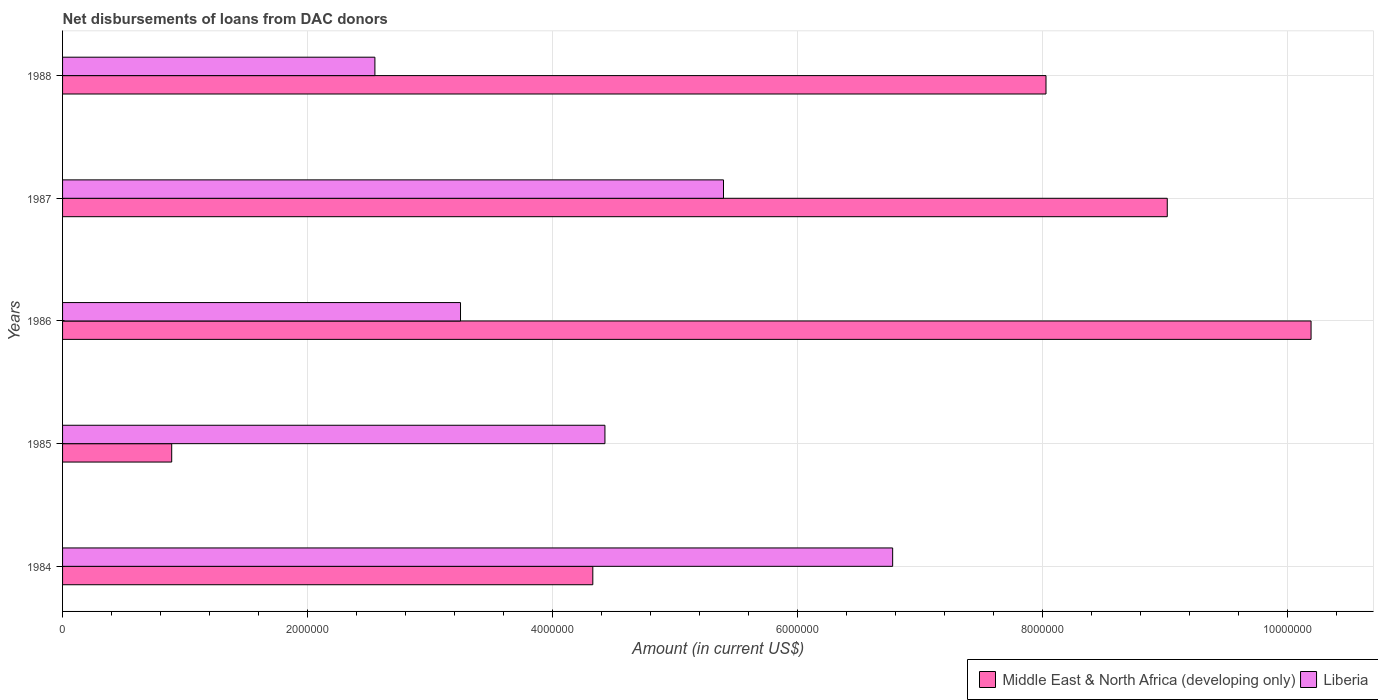Are the number of bars per tick equal to the number of legend labels?
Your response must be concise. Yes. Are the number of bars on each tick of the Y-axis equal?
Your answer should be very brief. Yes. In how many cases, is the number of bars for a given year not equal to the number of legend labels?
Provide a succinct answer. 0. What is the amount of loans disbursed in Liberia in 1988?
Your response must be concise. 2.55e+06. Across all years, what is the maximum amount of loans disbursed in Liberia?
Make the answer very short. 6.78e+06. Across all years, what is the minimum amount of loans disbursed in Liberia?
Provide a short and direct response. 2.55e+06. In which year was the amount of loans disbursed in Liberia maximum?
Your answer should be very brief. 1984. What is the total amount of loans disbursed in Middle East & North Africa (developing only) in the graph?
Provide a short and direct response. 3.25e+07. What is the difference between the amount of loans disbursed in Liberia in 1986 and that in 1987?
Offer a terse response. -2.15e+06. What is the difference between the amount of loans disbursed in Middle East & North Africa (developing only) in 1984 and the amount of loans disbursed in Liberia in 1986?
Offer a very short reply. 1.08e+06. What is the average amount of loans disbursed in Middle East & North Africa (developing only) per year?
Ensure brevity in your answer.  6.49e+06. In the year 1987, what is the difference between the amount of loans disbursed in Liberia and amount of loans disbursed in Middle East & North Africa (developing only)?
Provide a succinct answer. -3.62e+06. In how many years, is the amount of loans disbursed in Liberia greater than 2000000 US$?
Keep it short and to the point. 5. What is the ratio of the amount of loans disbursed in Middle East & North Africa (developing only) in 1984 to that in 1987?
Provide a short and direct response. 0.48. What is the difference between the highest and the second highest amount of loans disbursed in Middle East & North Africa (developing only)?
Your answer should be very brief. 1.17e+06. What is the difference between the highest and the lowest amount of loans disbursed in Liberia?
Make the answer very short. 4.23e+06. In how many years, is the amount of loans disbursed in Middle East & North Africa (developing only) greater than the average amount of loans disbursed in Middle East & North Africa (developing only) taken over all years?
Your response must be concise. 3. Is the sum of the amount of loans disbursed in Liberia in 1985 and 1988 greater than the maximum amount of loans disbursed in Middle East & North Africa (developing only) across all years?
Ensure brevity in your answer.  No. What does the 2nd bar from the top in 1984 represents?
Provide a succinct answer. Middle East & North Africa (developing only). What does the 2nd bar from the bottom in 1987 represents?
Your response must be concise. Liberia. Are all the bars in the graph horizontal?
Make the answer very short. Yes. Where does the legend appear in the graph?
Offer a very short reply. Bottom right. What is the title of the graph?
Your answer should be compact. Net disbursements of loans from DAC donors. Does "Zambia" appear as one of the legend labels in the graph?
Ensure brevity in your answer.  No. What is the label or title of the X-axis?
Provide a succinct answer. Amount (in current US$). What is the Amount (in current US$) in Middle East & North Africa (developing only) in 1984?
Your response must be concise. 4.33e+06. What is the Amount (in current US$) in Liberia in 1984?
Offer a very short reply. 6.78e+06. What is the Amount (in current US$) of Middle East & North Africa (developing only) in 1985?
Provide a succinct answer. 8.91e+05. What is the Amount (in current US$) of Liberia in 1985?
Keep it short and to the point. 4.43e+06. What is the Amount (in current US$) of Middle East & North Africa (developing only) in 1986?
Offer a very short reply. 1.02e+07. What is the Amount (in current US$) in Liberia in 1986?
Provide a succinct answer. 3.25e+06. What is the Amount (in current US$) of Middle East & North Africa (developing only) in 1987?
Provide a short and direct response. 9.02e+06. What is the Amount (in current US$) in Liberia in 1987?
Offer a very short reply. 5.40e+06. What is the Amount (in current US$) of Middle East & North Africa (developing only) in 1988?
Give a very brief answer. 8.03e+06. What is the Amount (in current US$) of Liberia in 1988?
Make the answer very short. 2.55e+06. Across all years, what is the maximum Amount (in current US$) of Middle East & North Africa (developing only)?
Your answer should be very brief. 1.02e+07. Across all years, what is the maximum Amount (in current US$) in Liberia?
Your answer should be very brief. 6.78e+06. Across all years, what is the minimum Amount (in current US$) of Middle East & North Africa (developing only)?
Ensure brevity in your answer.  8.91e+05. Across all years, what is the minimum Amount (in current US$) in Liberia?
Provide a short and direct response. 2.55e+06. What is the total Amount (in current US$) in Middle East & North Africa (developing only) in the graph?
Provide a succinct answer. 3.25e+07. What is the total Amount (in current US$) in Liberia in the graph?
Provide a short and direct response. 2.24e+07. What is the difference between the Amount (in current US$) in Middle East & North Africa (developing only) in 1984 and that in 1985?
Your answer should be compact. 3.44e+06. What is the difference between the Amount (in current US$) of Liberia in 1984 and that in 1985?
Your answer should be very brief. 2.35e+06. What is the difference between the Amount (in current US$) of Middle East & North Africa (developing only) in 1984 and that in 1986?
Provide a succinct answer. -5.86e+06. What is the difference between the Amount (in current US$) in Liberia in 1984 and that in 1986?
Provide a short and direct response. 3.53e+06. What is the difference between the Amount (in current US$) in Middle East & North Africa (developing only) in 1984 and that in 1987?
Keep it short and to the point. -4.69e+06. What is the difference between the Amount (in current US$) in Liberia in 1984 and that in 1987?
Give a very brief answer. 1.38e+06. What is the difference between the Amount (in current US$) in Middle East & North Africa (developing only) in 1984 and that in 1988?
Ensure brevity in your answer.  -3.70e+06. What is the difference between the Amount (in current US$) in Liberia in 1984 and that in 1988?
Ensure brevity in your answer.  4.23e+06. What is the difference between the Amount (in current US$) of Middle East & North Africa (developing only) in 1985 and that in 1986?
Give a very brief answer. -9.30e+06. What is the difference between the Amount (in current US$) in Liberia in 1985 and that in 1986?
Ensure brevity in your answer.  1.18e+06. What is the difference between the Amount (in current US$) in Middle East & North Africa (developing only) in 1985 and that in 1987?
Your response must be concise. -8.13e+06. What is the difference between the Amount (in current US$) of Liberia in 1985 and that in 1987?
Offer a terse response. -9.68e+05. What is the difference between the Amount (in current US$) in Middle East & North Africa (developing only) in 1985 and that in 1988?
Your answer should be compact. -7.14e+06. What is the difference between the Amount (in current US$) of Liberia in 1985 and that in 1988?
Offer a terse response. 1.88e+06. What is the difference between the Amount (in current US$) in Middle East & North Africa (developing only) in 1986 and that in 1987?
Provide a short and direct response. 1.17e+06. What is the difference between the Amount (in current US$) of Liberia in 1986 and that in 1987?
Keep it short and to the point. -2.15e+06. What is the difference between the Amount (in current US$) of Middle East & North Africa (developing only) in 1986 and that in 1988?
Offer a terse response. 2.16e+06. What is the difference between the Amount (in current US$) of Liberia in 1986 and that in 1988?
Ensure brevity in your answer.  6.99e+05. What is the difference between the Amount (in current US$) of Middle East & North Africa (developing only) in 1987 and that in 1988?
Your response must be concise. 9.90e+05. What is the difference between the Amount (in current US$) in Liberia in 1987 and that in 1988?
Keep it short and to the point. 2.85e+06. What is the difference between the Amount (in current US$) of Middle East & North Africa (developing only) in 1984 and the Amount (in current US$) of Liberia in 1985?
Give a very brief answer. -9.90e+04. What is the difference between the Amount (in current US$) of Middle East & North Africa (developing only) in 1984 and the Amount (in current US$) of Liberia in 1986?
Offer a terse response. 1.08e+06. What is the difference between the Amount (in current US$) in Middle East & North Africa (developing only) in 1984 and the Amount (in current US$) in Liberia in 1987?
Offer a terse response. -1.07e+06. What is the difference between the Amount (in current US$) in Middle East & North Africa (developing only) in 1984 and the Amount (in current US$) in Liberia in 1988?
Give a very brief answer. 1.78e+06. What is the difference between the Amount (in current US$) in Middle East & North Africa (developing only) in 1985 and the Amount (in current US$) in Liberia in 1986?
Make the answer very short. -2.36e+06. What is the difference between the Amount (in current US$) in Middle East & North Africa (developing only) in 1985 and the Amount (in current US$) in Liberia in 1987?
Provide a succinct answer. -4.50e+06. What is the difference between the Amount (in current US$) of Middle East & North Africa (developing only) in 1985 and the Amount (in current US$) of Liberia in 1988?
Your answer should be compact. -1.66e+06. What is the difference between the Amount (in current US$) of Middle East & North Africa (developing only) in 1986 and the Amount (in current US$) of Liberia in 1987?
Your answer should be very brief. 4.80e+06. What is the difference between the Amount (in current US$) of Middle East & North Africa (developing only) in 1986 and the Amount (in current US$) of Liberia in 1988?
Your answer should be compact. 7.64e+06. What is the difference between the Amount (in current US$) in Middle East & North Africa (developing only) in 1987 and the Amount (in current US$) in Liberia in 1988?
Provide a succinct answer. 6.47e+06. What is the average Amount (in current US$) of Middle East & North Africa (developing only) per year?
Give a very brief answer. 6.49e+06. What is the average Amount (in current US$) in Liberia per year?
Your answer should be compact. 4.48e+06. In the year 1984, what is the difference between the Amount (in current US$) in Middle East & North Africa (developing only) and Amount (in current US$) in Liberia?
Offer a very short reply. -2.45e+06. In the year 1985, what is the difference between the Amount (in current US$) in Middle East & North Africa (developing only) and Amount (in current US$) in Liberia?
Your answer should be compact. -3.54e+06. In the year 1986, what is the difference between the Amount (in current US$) in Middle East & North Africa (developing only) and Amount (in current US$) in Liberia?
Offer a very short reply. 6.94e+06. In the year 1987, what is the difference between the Amount (in current US$) of Middle East & North Africa (developing only) and Amount (in current US$) of Liberia?
Make the answer very short. 3.62e+06. In the year 1988, what is the difference between the Amount (in current US$) in Middle East & North Africa (developing only) and Amount (in current US$) in Liberia?
Offer a terse response. 5.48e+06. What is the ratio of the Amount (in current US$) in Middle East & North Africa (developing only) in 1984 to that in 1985?
Provide a succinct answer. 4.86. What is the ratio of the Amount (in current US$) of Liberia in 1984 to that in 1985?
Give a very brief answer. 1.53. What is the ratio of the Amount (in current US$) of Middle East & North Africa (developing only) in 1984 to that in 1986?
Offer a terse response. 0.42. What is the ratio of the Amount (in current US$) in Liberia in 1984 to that in 1986?
Make the answer very short. 2.09. What is the ratio of the Amount (in current US$) in Middle East & North Africa (developing only) in 1984 to that in 1987?
Ensure brevity in your answer.  0.48. What is the ratio of the Amount (in current US$) in Liberia in 1984 to that in 1987?
Provide a short and direct response. 1.26. What is the ratio of the Amount (in current US$) of Middle East & North Africa (developing only) in 1984 to that in 1988?
Offer a very short reply. 0.54. What is the ratio of the Amount (in current US$) in Liberia in 1984 to that in 1988?
Ensure brevity in your answer.  2.66. What is the ratio of the Amount (in current US$) in Middle East & North Africa (developing only) in 1985 to that in 1986?
Provide a short and direct response. 0.09. What is the ratio of the Amount (in current US$) in Liberia in 1985 to that in 1986?
Provide a succinct answer. 1.36. What is the ratio of the Amount (in current US$) of Middle East & North Africa (developing only) in 1985 to that in 1987?
Provide a short and direct response. 0.1. What is the ratio of the Amount (in current US$) of Liberia in 1985 to that in 1987?
Your answer should be compact. 0.82. What is the ratio of the Amount (in current US$) of Middle East & North Africa (developing only) in 1985 to that in 1988?
Offer a terse response. 0.11. What is the ratio of the Amount (in current US$) in Liberia in 1985 to that in 1988?
Provide a short and direct response. 1.74. What is the ratio of the Amount (in current US$) in Middle East & North Africa (developing only) in 1986 to that in 1987?
Keep it short and to the point. 1.13. What is the ratio of the Amount (in current US$) in Liberia in 1986 to that in 1987?
Offer a terse response. 0.6. What is the ratio of the Amount (in current US$) of Middle East & North Africa (developing only) in 1986 to that in 1988?
Your answer should be very brief. 1.27. What is the ratio of the Amount (in current US$) in Liberia in 1986 to that in 1988?
Offer a very short reply. 1.27. What is the ratio of the Amount (in current US$) of Middle East & North Africa (developing only) in 1987 to that in 1988?
Give a very brief answer. 1.12. What is the ratio of the Amount (in current US$) of Liberia in 1987 to that in 1988?
Your response must be concise. 2.12. What is the difference between the highest and the second highest Amount (in current US$) of Middle East & North Africa (developing only)?
Offer a terse response. 1.17e+06. What is the difference between the highest and the second highest Amount (in current US$) of Liberia?
Your answer should be compact. 1.38e+06. What is the difference between the highest and the lowest Amount (in current US$) of Middle East & North Africa (developing only)?
Offer a terse response. 9.30e+06. What is the difference between the highest and the lowest Amount (in current US$) in Liberia?
Make the answer very short. 4.23e+06. 